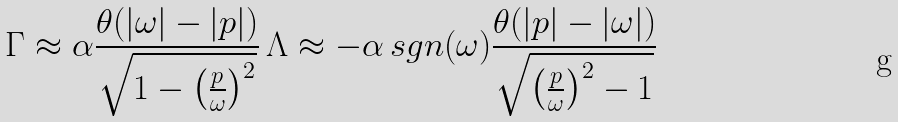Convert formula to latex. <formula><loc_0><loc_0><loc_500><loc_500>\Gamma \approx \alpha \frac { \theta ( | \omega | - | p | ) } { \sqrt { 1 - \left ( \frac { p } { \omega } \right ) ^ { 2 } } } \, \Lambda \approx - \alpha \, s g n ( \omega ) \frac { \theta ( | p | - | \omega | ) } { \sqrt { \left ( \frac { p } { \omega } \right ) ^ { 2 } - 1 } }</formula> 